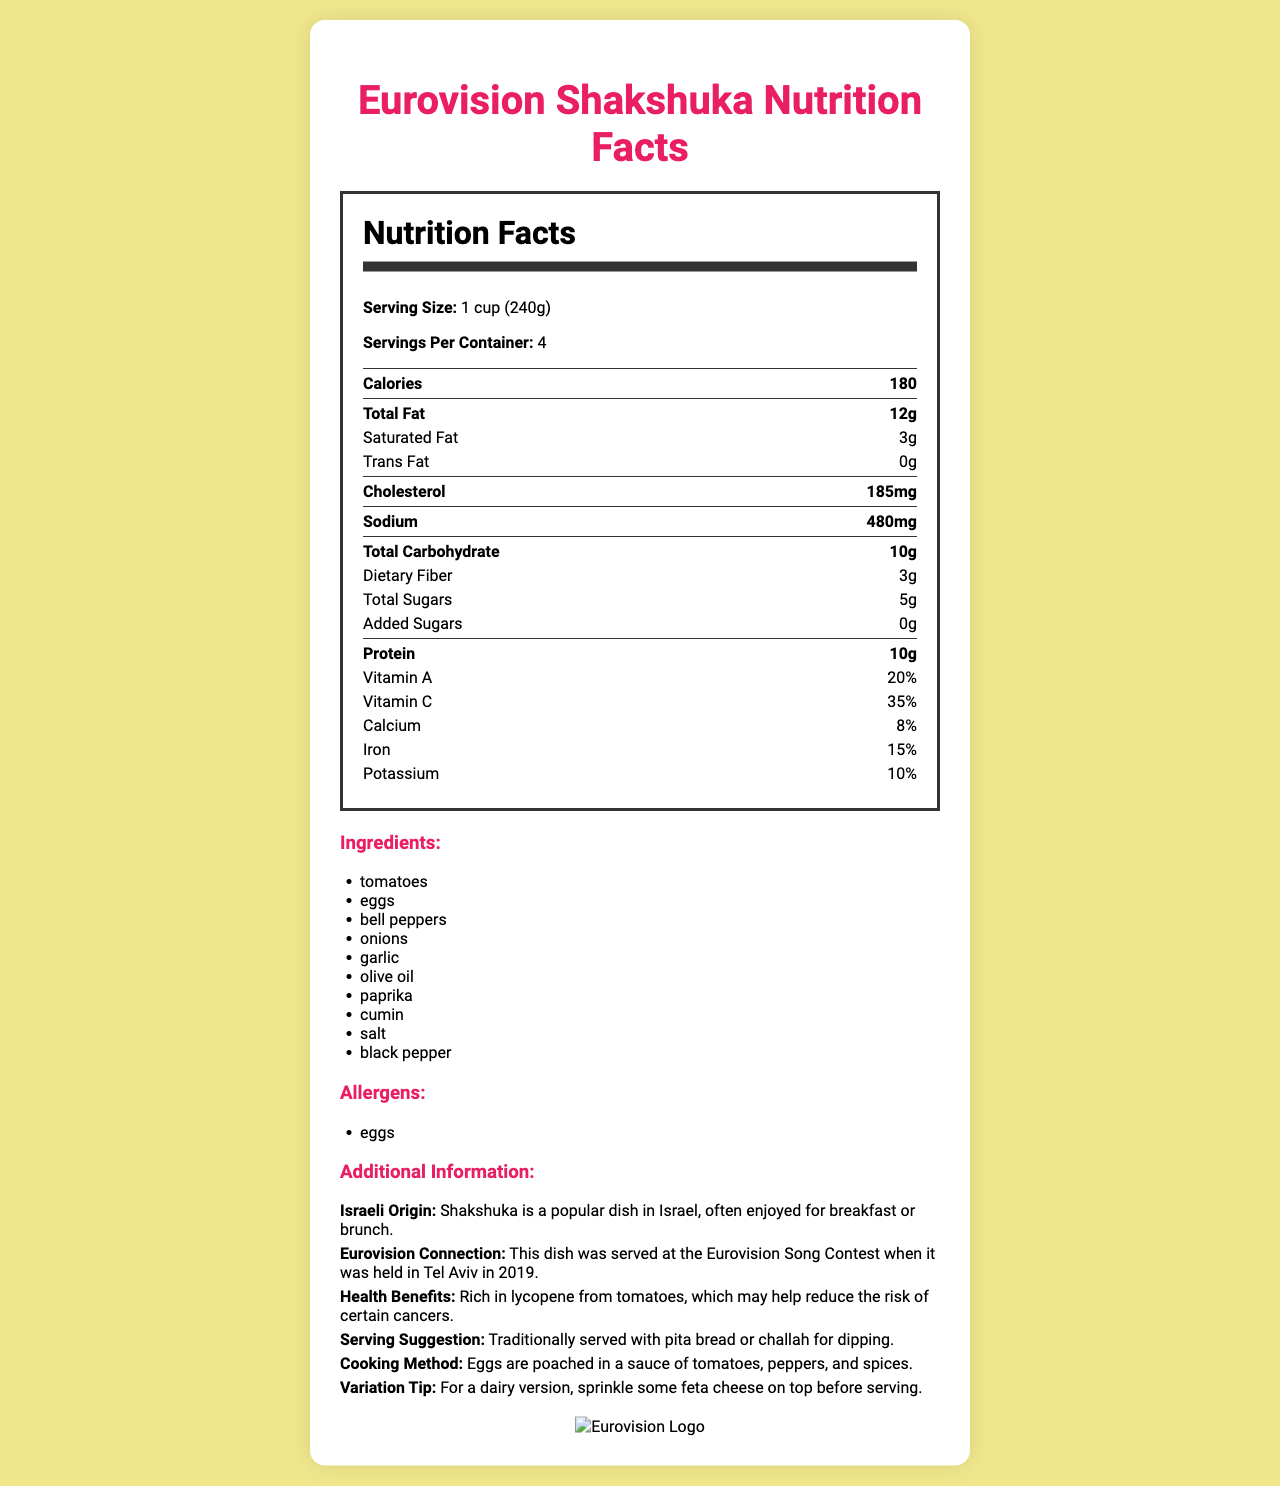what is the serving size for the shakshuka? The serving size is listed near the top of the Nutrition Facts section as "Serving Size: 1 cup (240g)."
Answer: 1 cup (240g) how many servings per container are there? The document specifies "Servings Per Container: 4" right below the serving size.
Answer: 4 how many grams of total fat does one serving of shakshuka contain? Under the Nutrition Facts, "Total Fat" is listed as 12g per serving.
Answer: 12g what vitamin percentage does shakshuka provide from the daily value of Vitamin A? The Nutrition Facts list "Vitamin A 20%" as part of the daily value contributions.
Answer: 20% name the ingredients used in shakshuka. The document lists the ingredients under the "Ingredients" section.
Answer: Tomatoes, eggs, bell peppers, onions, garlic, olive oil, paprika, cumin, salt, black pepper which of the following is an allergen in shakshuka? A. Dairy B. Nuts C. Eggs D. Gluten The allergen section lists "eggs" as an allergen, and "eggs" is the correct option among the choices.
Answer: C. Eggs how many grams of dietary fiber does one serving provide? A. 1g B. 2g C. 3g D. 4g The document states "Dietary Fiber 3g" under the Nutrition Facts.
Answer: C. 3g is shakshuka a common dish in Israel? The additional information section notes that shakshuka is a popular dish in Israel, often enjoyed for breakfast or brunch.
Answer: Yes was shakshuka served at the Eurovision Song Contest in Tel Aviv in 2019? The additional information section explicitly mentions that this dish was served at the Eurovision Song Contest when it was held in Tel Aviv in 2019.
Answer: Yes summarize the main idea of this document. The document is a comprehensive summary of the nutrition facts and key information about shakshuka, including its connection to Israel and the Eurovision Song Contest.
Answer: This document provides the nutrition facts, ingredients, and additional information for a traditional Israeli shakshuka dish. It details the serving size, servings per container, calorie content, and specific nutrient amounts. The document also highlights the dish's Israeli origin, its connection to the Eurovision Song Contest, and suggests how to serve and variate the dish. Allergens and health benefits are also mentioned. what are the health benefits mentioned for shakshuka? The additional information section specifies the health benefits as being rich in lycopene from tomatoes, potentially reducing the risk of certain cancers.
Answer: Rich in lycopene from tomatoes, which may help reduce the risk of certain cancers. how many grams of protein are in each serving of shakshuka? The Nutrition Facts state "Protein 10g" per serving.
Answer: 10g does shakshuka contain any trans fat? The document clearly lists "Trans Fat 0g" in the Nutrition Facts.
Answer: No how is shakshuka traditionally served according to the document? The additional information section suggests shakshuka is traditionally served with pita bread or challah for dipping.
Answer: With pita bread or challah for dipping does the document provide the exact recipe or cooking steps for shakshuka? While the document mentions the cooking method briefly (eggs poached in tomato, pepper, and spices sauce), it does not provide an exact recipe or detailed cooking steps.
Answer: Not enough information 